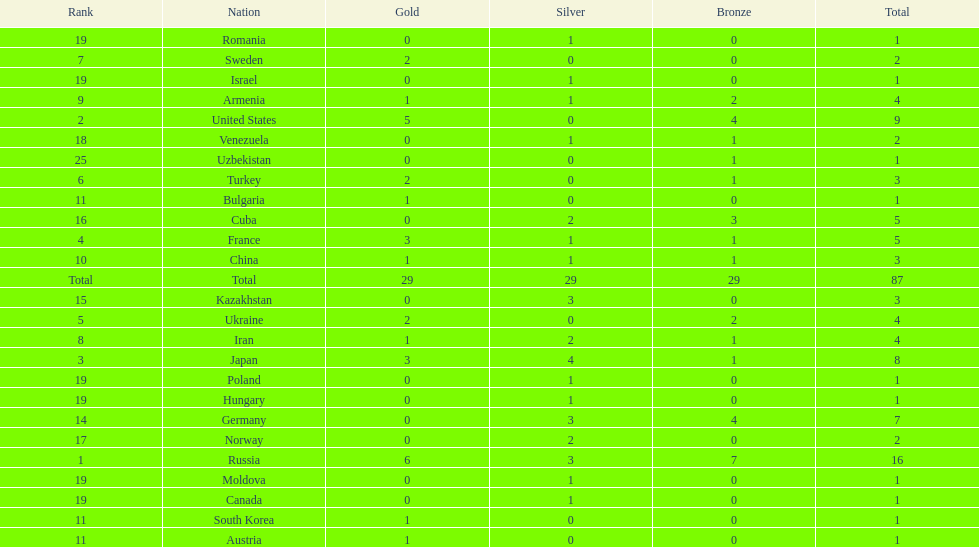Which nations are there? Russia, 6, United States, 5, Japan, 3, France, 3, Ukraine, 2, Turkey, 2, Sweden, 2, Iran, 1, Armenia, 1, China, 1, Austria, 1, Bulgaria, 1, South Korea, 1, Germany, 0, Kazakhstan, 0, Cuba, 0, Norway, 0, Venezuela, 0, Canada, 0, Hungary, 0, Israel, 0, Moldova, 0, Poland, 0, Romania, 0, Uzbekistan, 0. Which nations won gold? Russia, 6, United States, 5, Japan, 3, France, 3, Ukraine, 2, Turkey, 2, Sweden, 2, Iran, 1, Armenia, 1, China, 1, Austria, 1, Bulgaria, 1, South Korea, 1. How many golds did united states win? United States, 5. Which country has more than 5 gold medals? Russia, 6. What country is it? Russia. 